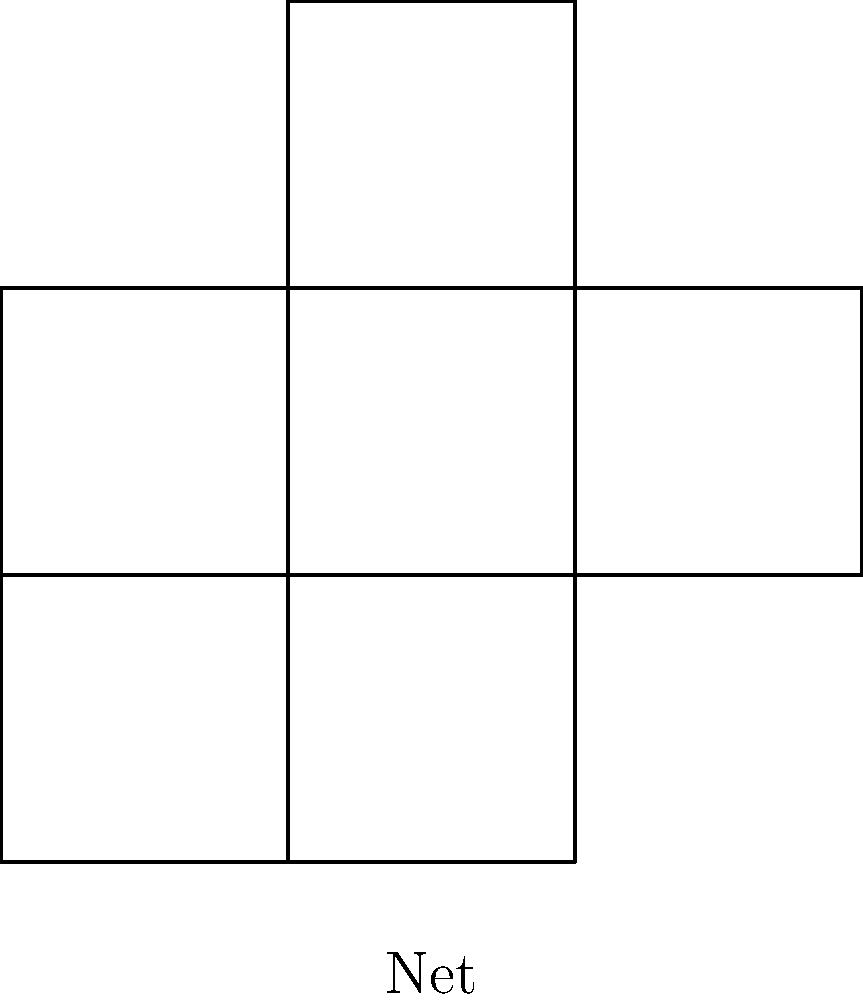As someone who has experienced brain lesions, you understand the importance of spatial reasoning in daily life. Look at the 2D net on the left and imagine folding it along the edges. Which 3D shape on the right would be formed? Let's approach this step-by-step:

1. First, we need to identify the shape of the net. It consists of 6 square faces connected in a specific pattern.

2. Next, let's mentally fold the net:
   - The central square will form the base.
   - The four squares attached to each side of the base will fold up to form the sides.
   - The square attached to the top will fold over to form the top face.

3. As we fold, we can observe that:
   - All faces are square-shaped.
   - There are exactly 6 faces.
   - Each face is connected to four other faces along its edges.

4. These characteristics are unique to a cube:
   - A cube has 6 square faces.
   - Each face of a cube is connected to 4 other faces.

5. The 3D shape shown on the right is indeed a cube, which matches our mental folding of the net.

This spatial reasoning exercise is beneficial for cognitive rehabilitation after brain lesions, as it helps strengthen visual-spatial processing and mental manipulation skills.
Answer: Cube 